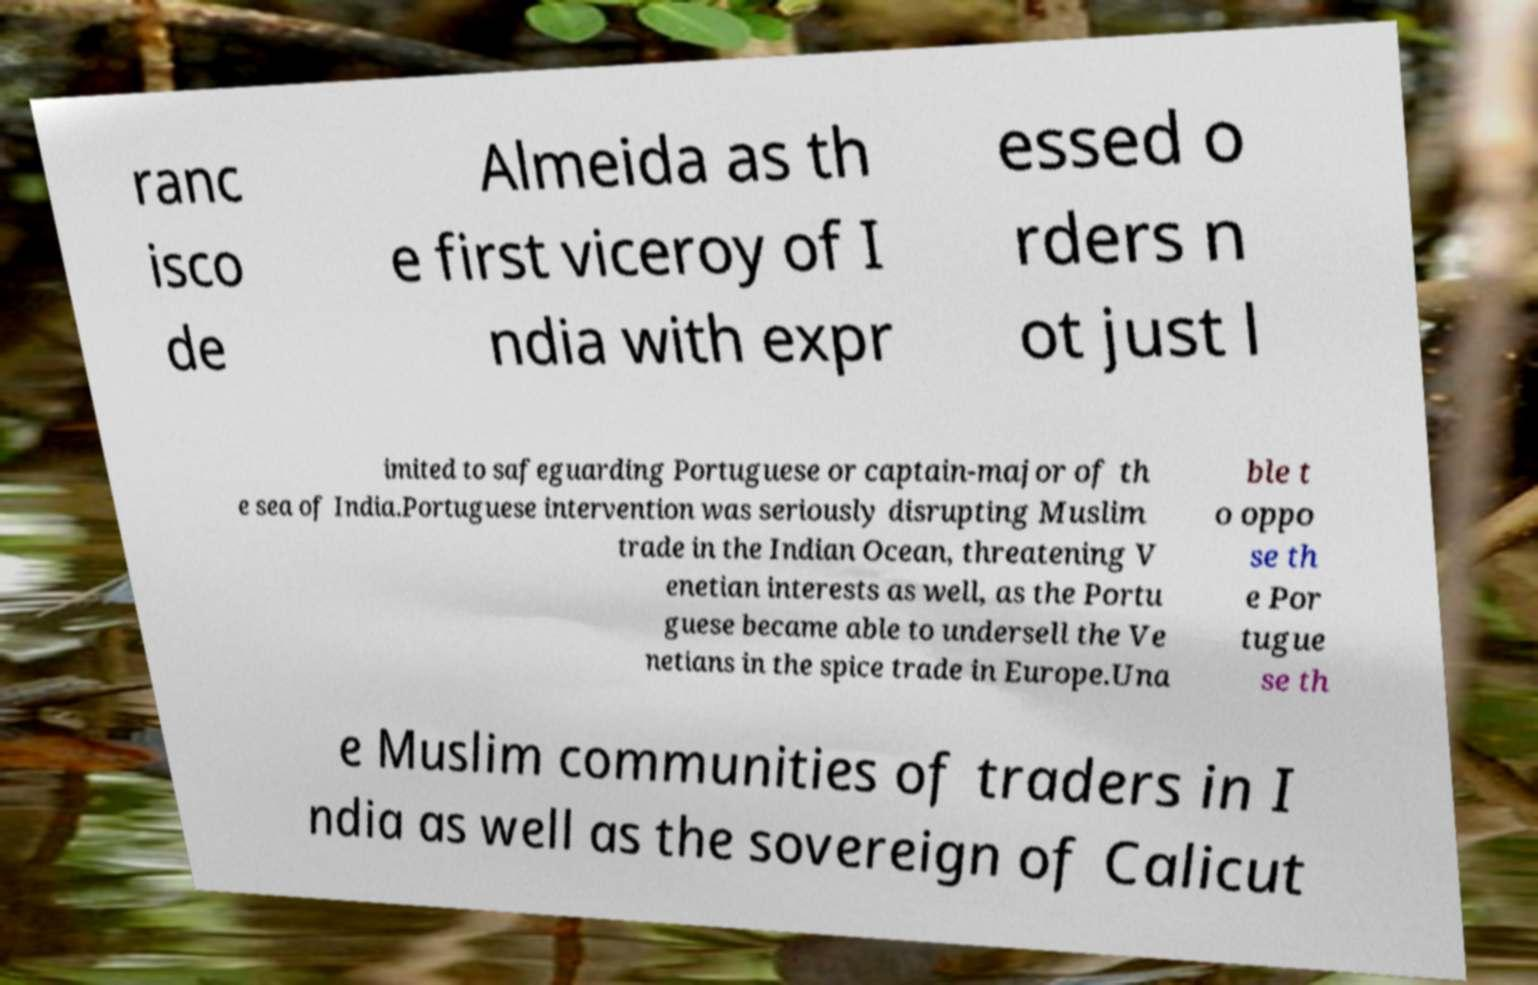Could you assist in decoding the text presented in this image and type it out clearly? ranc isco de Almeida as th e first viceroy of I ndia with expr essed o rders n ot just l imited to safeguarding Portuguese or captain-major of th e sea of India.Portuguese intervention was seriously disrupting Muslim trade in the Indian Ocean, threatening V enetian interests as well, as the Portu guese became able to undersell the Ve netians in the spice trade in Europe.Una ble t o oppo se th e Por tugue se th e Muslim communities of traders in I ndia as well as the sovereign of Calicut 